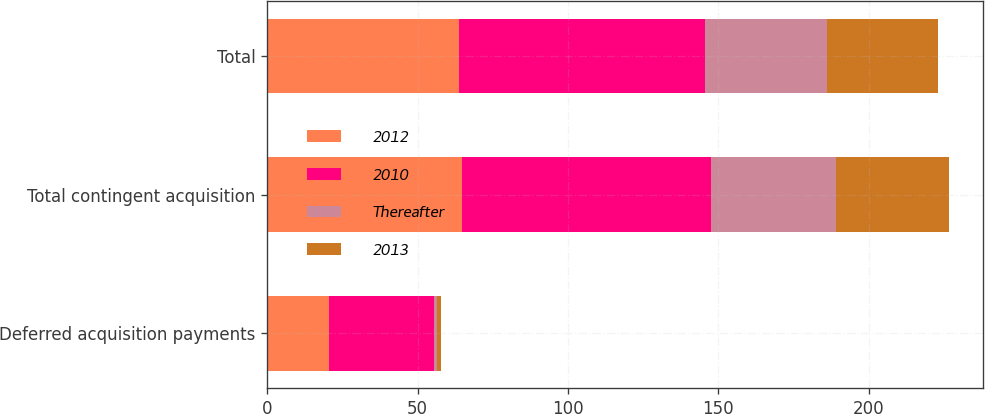<chart> <loc_0><loc_0><loc_500><loc_500><stacked_bar_chart><ecel><fcel>Deferred acquisition payments<fcel>Total contingent acquisition<fcel>Total<nl><fcel>2012<fcel>20.5<fcel>64.9<fcel>63.9<nl><fcel>2010<fcel>34.8<fcel>82.7<fcel>81.7<nl><fcel>Thereafter<fcel>1.2<fcel>41.7<fcel>40.7<nl><fcel>2013<fcel>1.1<fcel>37.4<fcel>36.9<nl></chart> 